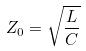Convert formula to latex. <formula><loc_0><loc_0><loc_500><loc_500>Z _ { 0 } = \sqrt { \frac { L } { C } }</formula> 